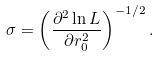<formula> <loc_0><loc_0><loc_500><loc_500>\sigma = \left ( \frac { \partial ^ { 2 } \ln L } { \partial r _ { 0 } ^ { 2 } } \right ) ^ { - 1 / 2 } .</formula> 